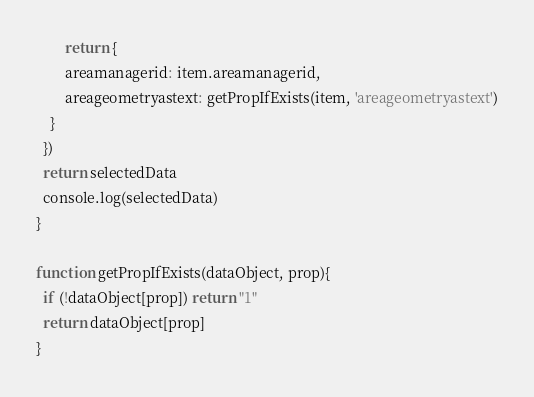<code> <loc_0><loc_0><loc_500><loc_500><_JavaScript_>		return {
    	areamanagerid: item.areamanagerid,
    	areageometryastext: getPropIfExists(item, 'areageometryastext')
    }
  })
  return selectedData
  console.log(selectedData)
}

function getPropIfExists(dataObject, prop){
  if (!dataObject[prop]) return "1"
  return dataObject[prop]
}</code> 